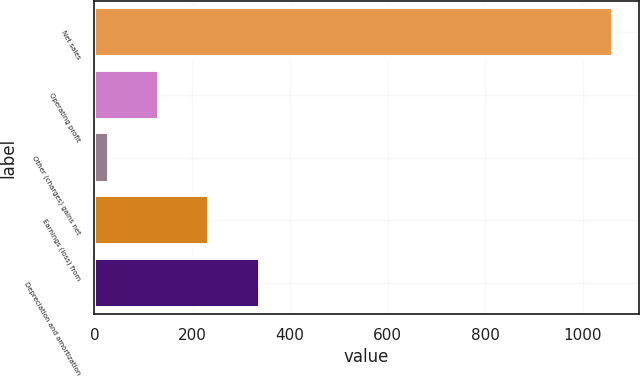<chart> <loc_0><loc_0><loc_500><loc_500><bar_chart><fcel>Net sales<fcel>Operating profit<fcel>Other (charges) gains net<fcel>Earnings (loss) from<fcel>Depreciation and amortization<nl><fcel>1061<fcel>132.2<fcel>29<fcel>235.4<fcel>338.6<nl></chart> 